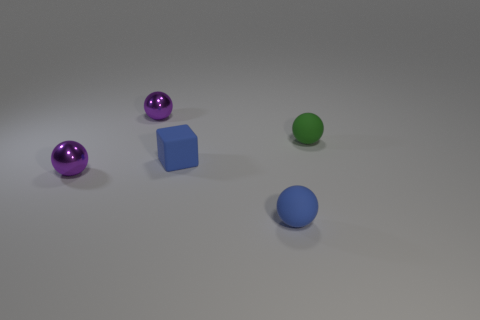The shiny ball behind the green thing is what color? The shiny ball positioned behind the green object in the image is a rich shade of purple, reflecting light in such a way that gives it a luminous and almost metallic appearance. 